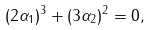<formula> <loc_0><loc_0><loc_500><loc_500>( 2 \alpha _ { 1 } ) ^ { 3 } + ( 3 \alpha _ { 2 } ) ^ { 2 } = 0 ,</formula> 